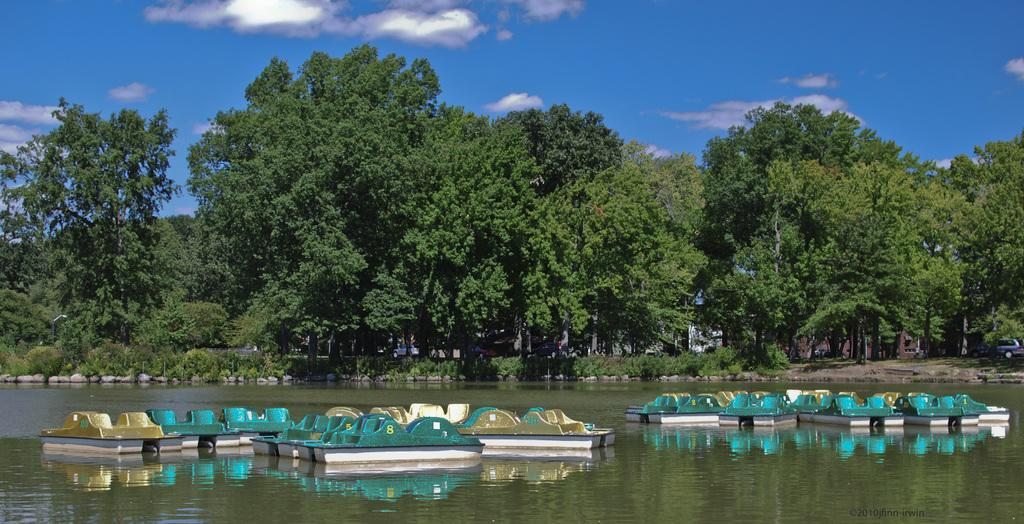What is in the water in the image? There are boats in the water in the image. What can be seen in the background of the image? In the background, there are plants, the ground, vehicles, trees, and the sky with clouds. Can you describe the setting of the image? The image shows boats in the water, with a background that includes various natural and man-made elements. What type of lumber is being sold at the market in the image? There is no market or lumber present in the image; it features boats in the water and various background elements. How many sticks can be seen in the image? There are no sticks visible in the image. 